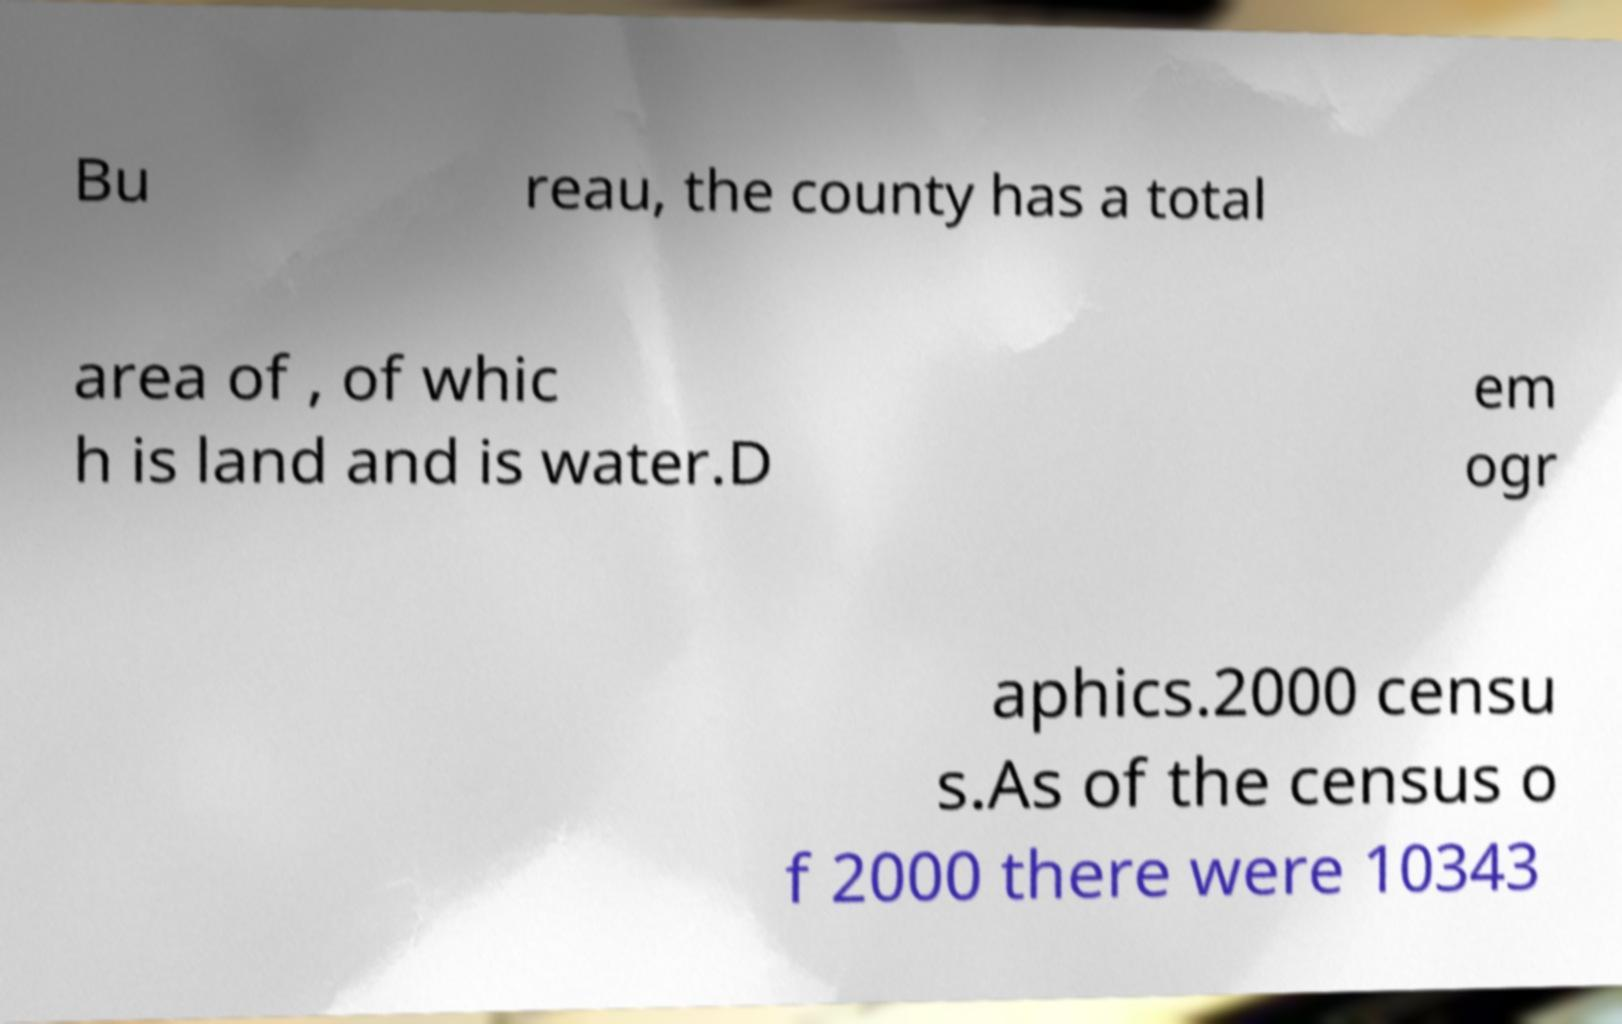Could you extract and type out the text from this image? Bu reau, the county has a total area of , of whic h is land and is water.D em ogr aphics.2000 censu s.As of the census o f 2000 there were 10343 